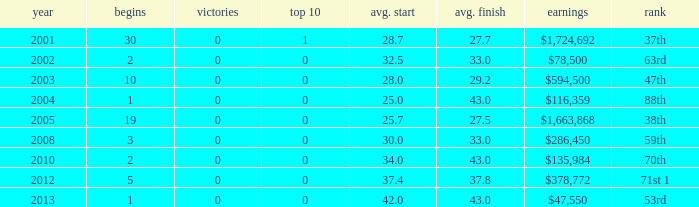What is the average top 10 score for 2 starts, winnings of $135,984 and an average finish more than 43? None. 